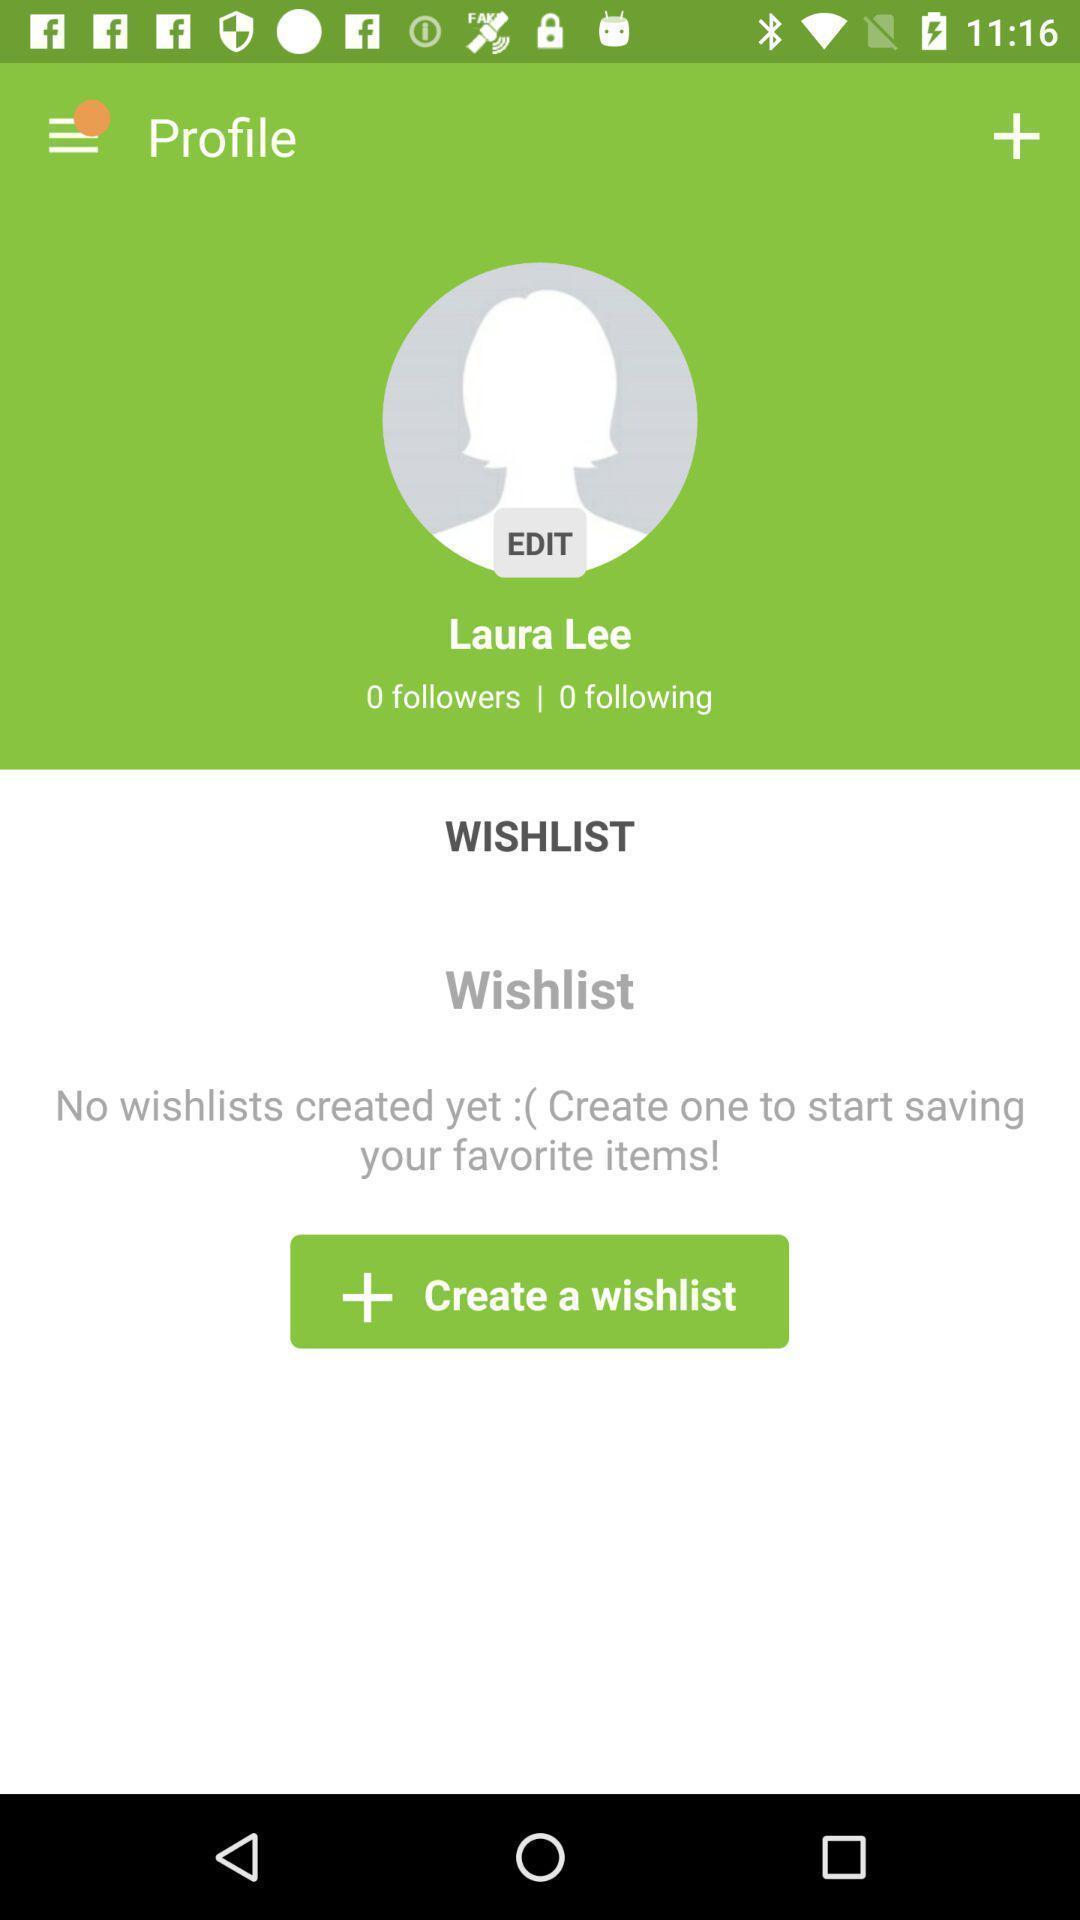Describe this image in words. Screen shows profile details of a person. 